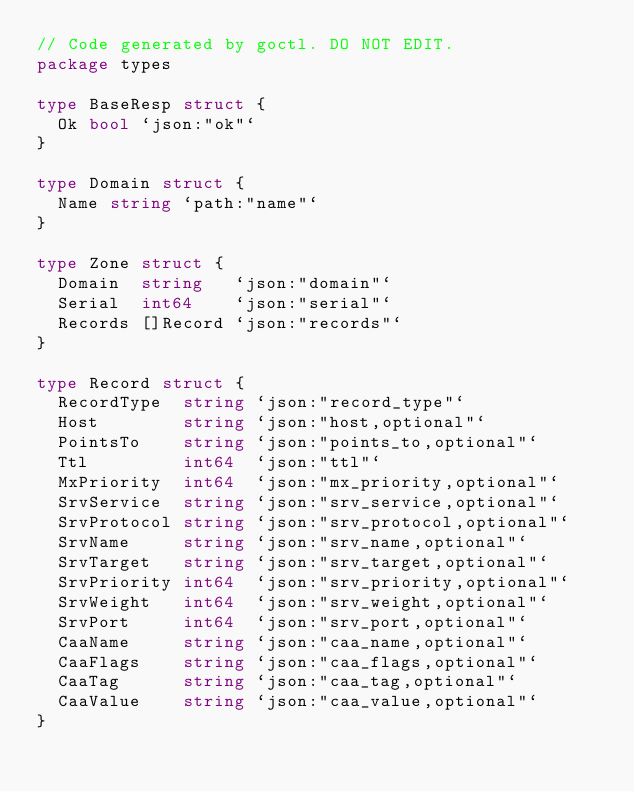Convert code to text. <code><loc_0><loc_0><loc_500><loc_500><_Go_>// Code generated by goctl. DO NOT EDIT.
package types

type BaseResp struct {
	Ok bool `json:"ok"`
}

type Domain struct {
	Name string `path:"name"`
}

type Zone struct {
	Domain  string   `json:"domain"`
	Serial  int64    `json:"serial"`
	Records []Record `json:"records"`
}

type Record struct {
	RecordType  string `json:"record_type"`
	Host        string `json:"host,optional"`
	PointsTo    string `json:"points_to,optional"`
	Ttl         int64  `json:"ttl"`
	MxPriority  int64  `json:"mx_priority,optional"`
	SrvService  string `json:"srv_service,optional"`
	SrvProtocol string `json:"srv_protocol,optional"`
	SrvName     string `json:"srv_name,optional"`
	SrvTarget   string `json:"srv_target,optional"`
	SrvPriority int64  `json:"srv_priority,optional"`
	SrvWeight   int64  `json:"srv_weight,optional"`
	SrvPort     int64  `json:"srv_port,optional"`
	CaaName     string `json:"caa_name,optional"`
	CaaFlags    string `json:"caa_flags,optional"`
	CaaTag      string `json:"caa_tag,optional"`
	CaaValue    string `json:"caa_value,optional"`
}
</code> 